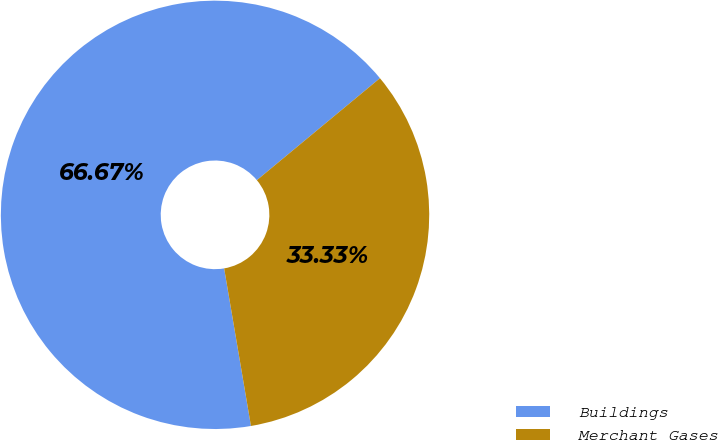Convert chart to OTSL. <chart><loc_0><loc_0><loc_500><loc_500><pie_chart><fcel>Buildings<fcel>Merchant Gases<nl><fcel>66.67%<fcel>33.33%<nl></chart> 